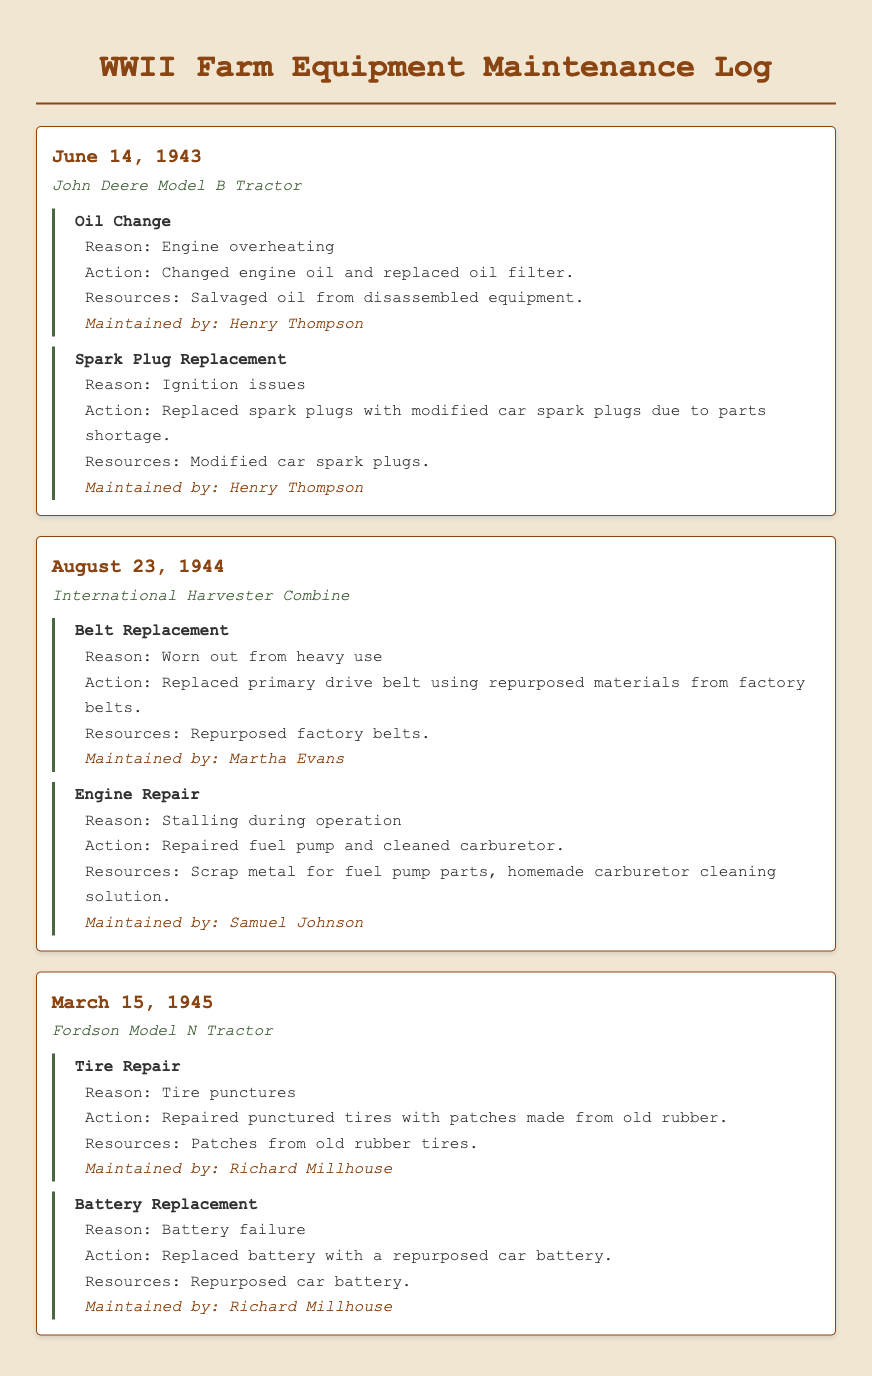What equipment had an oil change on June 14, 1943? The document states that the oil change was performed on the John Deere Model B Tractor on June 14, 1943.
Answer: John Deere Model B Tractor Who maintained the Fordson Model N Tractor? The document indicates that Richard Millhouse was responsible for maintaining the Fordson Model N Tractor.
Answer: Richard Millhouse What was the reason for replacing the spark plugs in the John Deere Model B Tractor? The reason given in the document for replacing the spark plugs was ignition issues.
Answer: Ignition issues What materials were used for the primary drive belt replacement? The log specifies that the primary drive belt was replaced using repurposed materials from factory belts.
Answer: Repurposed materials from factory belts What maintenance action was taken on August 23, 1944? The maintenance action taken on that date included the belt replacement and engine repair for the International Harvester Combine.
Answer: Belt replacement and engine repair How many maintenance tasks were documented for the John Deere Model B Tractor? The log shows two maintenance tasks documented for the John Deere Model B Tractor: an oil change and a spark plug replacement.
Answer: Two What did the maintenance person use for tire repairs on the Fordson Model N Tractor? The document states that patches from old rubber tires were used for the tire repairs.
Answer: Patches from old rubber tires What type of tractor is listed in the log for June 14, 1943? According to the document, the type of tractor listed for that date is the John Deere Model B Tractor.
Answer: John Deere Model B Tractor What was the maintenance action performed to address engine overheating in the John Deere Model B Tractor? The document details that an oil change was performed to address the engine overheating issue.
Answer: Oil Change 